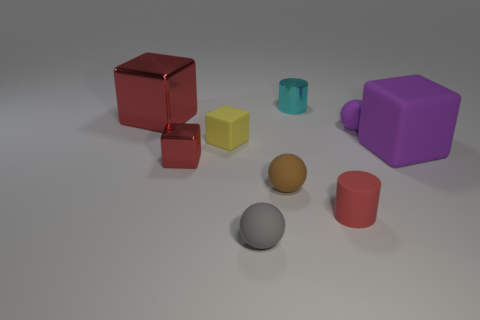Subtract all large red metallic cubes. How many cubes are left? 3 Subtract all purple spheres. How many spheres are left? 2 Subtract all balls. How many objects are left? 6 Subtract 1 balls. How many balls are left? 2 Add 4 small blue shiny cylinders. How many small blue shiny cylinders exist? 4 Subtract 0 green cylinders. How many objects are left? 9 Subtract all gray cylinders. Subtract all cyan cubes. How many cylinders are left? 2 Subtract all gray spheres. How many purple cubes are left? 1 Subtract all big red shiny blocks. Subtract all large purple objects. How many objects are left? 7 Add 4 red objects. How many red objects are left? 7 